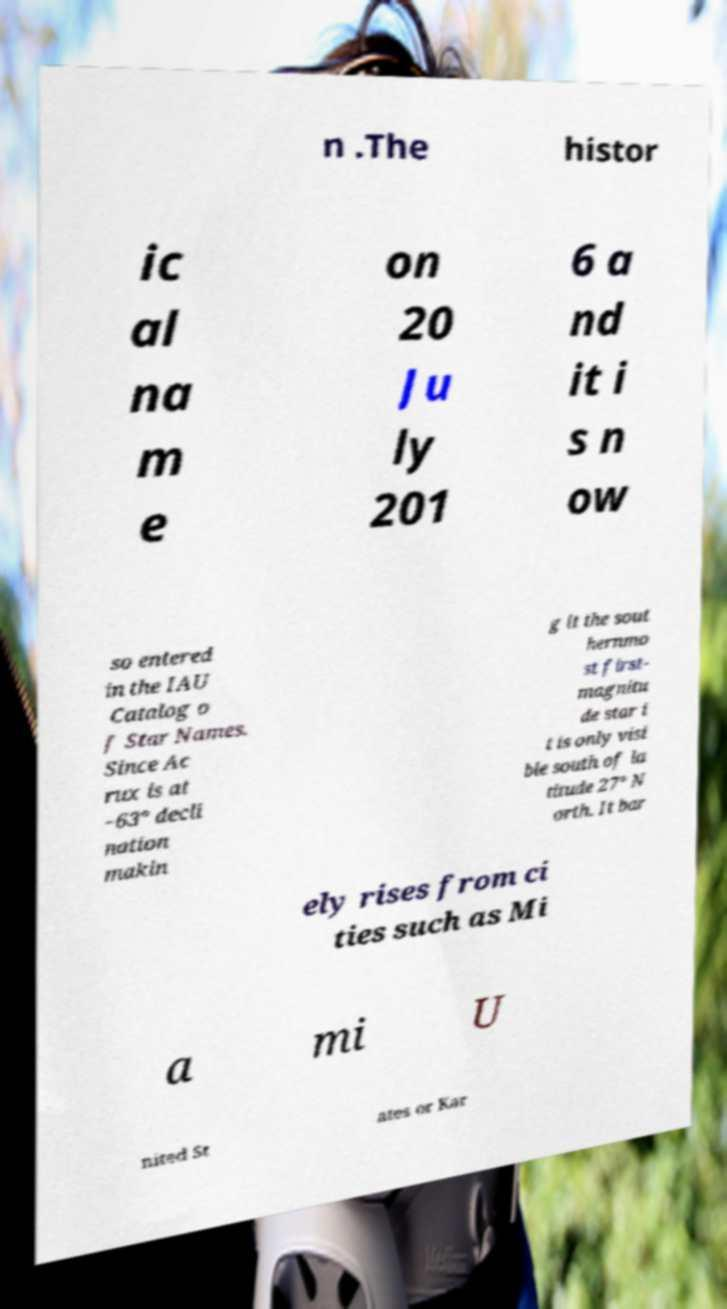There's text embedded in this image that I need extracted. Can you transcribe it verbatim? n .The histor ic al na m e on 20 Ju ly 201 6 a nd it i s n ow so entered in the IAU Catalog o f Star Names. Since Ac rux is at −63° decli nation makin g it the sout hernmo st first- magnitu de star i t is only visi ble south of la titude 27° N orth. It bar ely rises from ci ties such as Mi a mi U nited St ates or Kar 